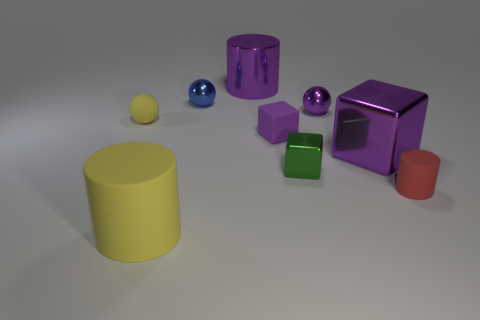Subtract all tiny red rubber cylinders. How many cylinders are left? 2 Add 1 cylinders. How many objects exist? 10 Subtract all red spheres. How many purple blocks are left? 2 Subtract 1 cubes. How many cubes are left? 2 Subtract all cubes. How many objects are left? 6 Add 7 red matte cylinders. How many red matte cylinders exist? 8 Subtract 0 brown cubes. How many objects are left? 9 Subtract all purple cylinders. Subtract all cyan balls. How many cylinders are left? 2 Subtract all yellow matte things. Subtract all small purple shiny spheres. How many objects are left? 6 Add 5 yellow matte cylinders. How many yellow matte cylinders are left? 6 